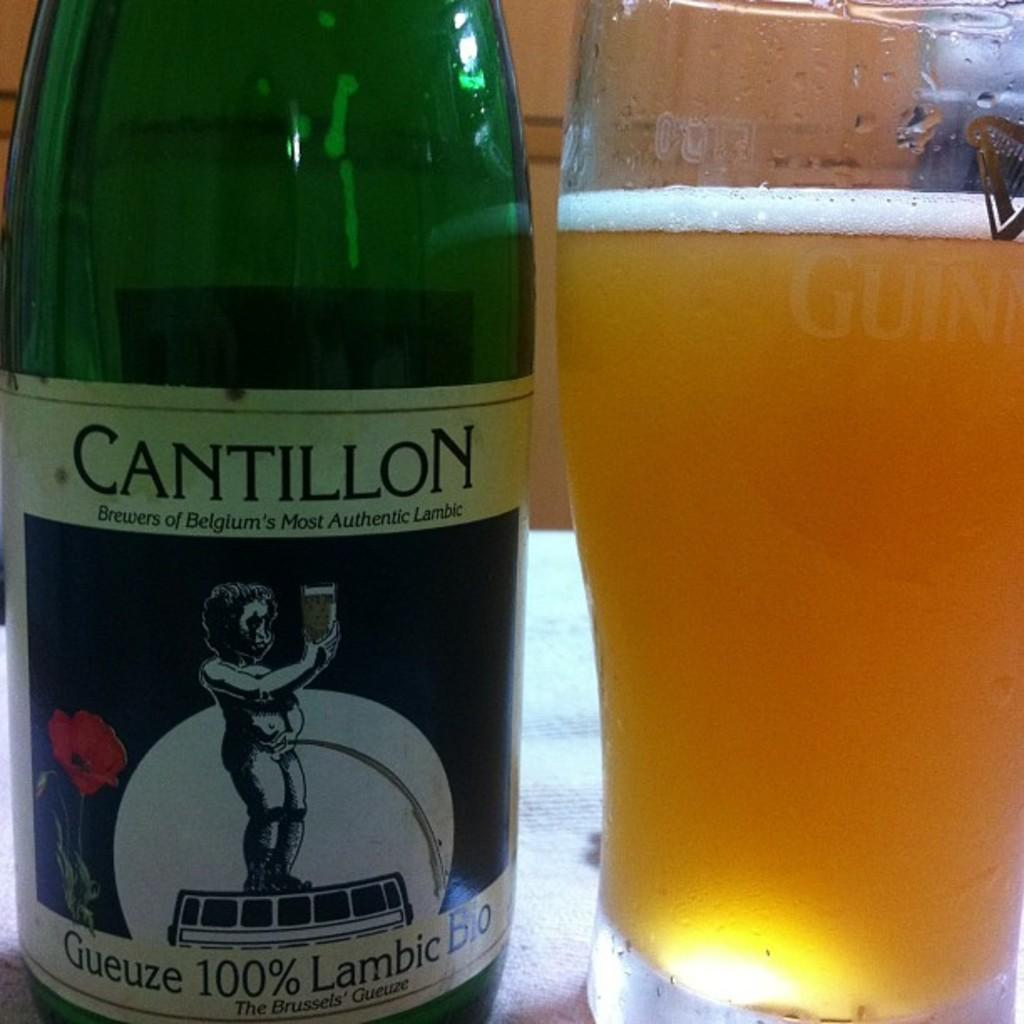What type of bottle is on the table in the image? There is a green glass bottle on the table in the image. What is the color of the glass beside the green glass bottle? The glass beside the green glass bottle is also clear. Can you describe the wilderness surrounding the table in the image? There is no wilderness present in the image; it only shows a table with a green glass bottle and a clear glass on it. 